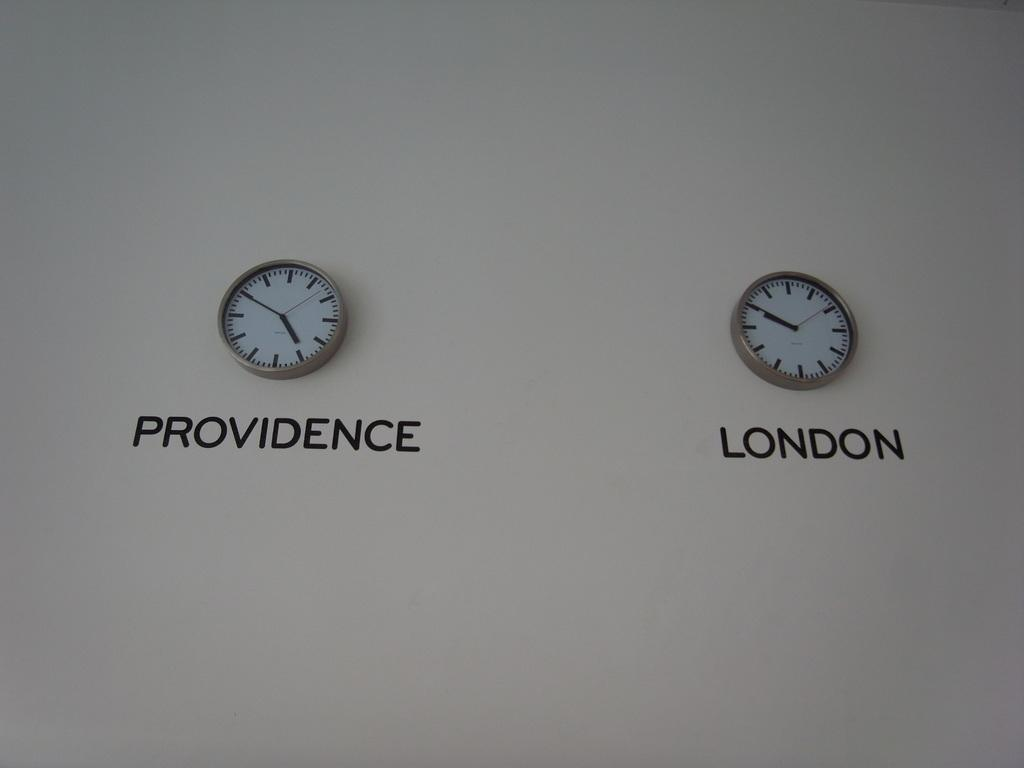<image>
Write a terse but informative summary of the picture. the city of London that is on a clock 